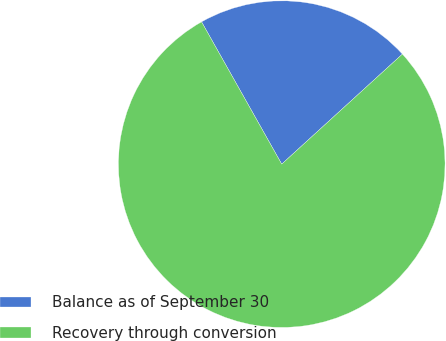<chart> <loc_0><loc_0><loc_500><loc_500><pie_chart><fcel>Balance as of September 30<fcel>Recovery through conversion<nl><fcel>21.4%<fcel>78.6%<nl></chart> 